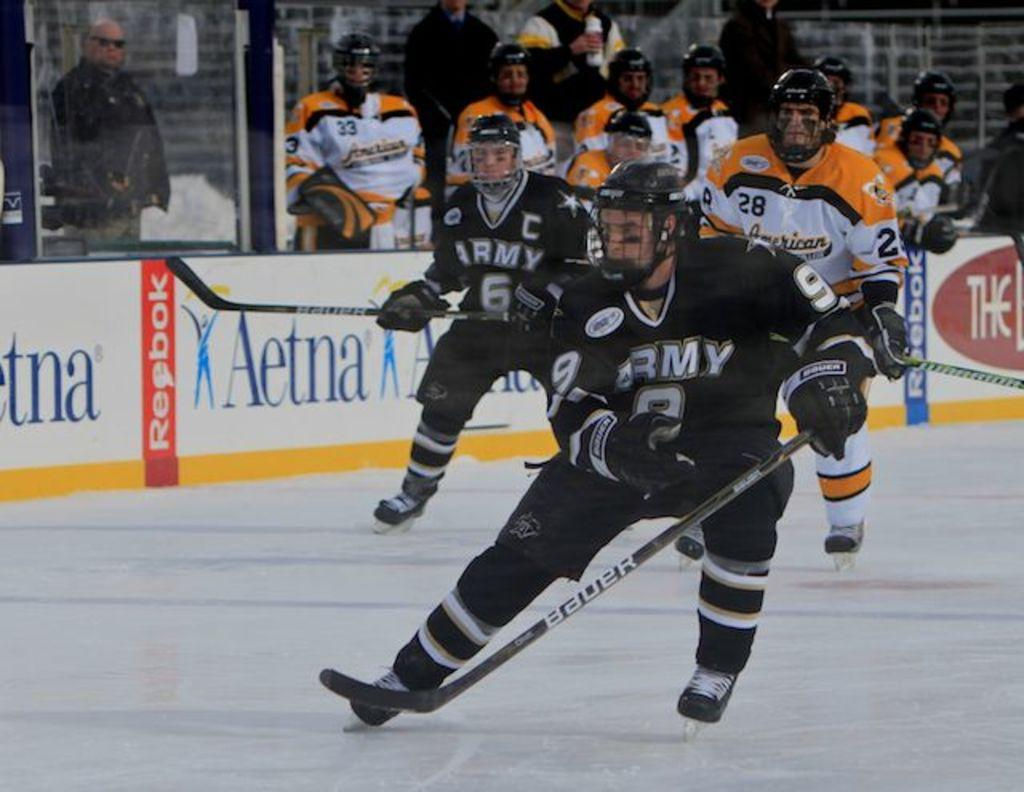<image>
Summarize the visual content of the image. Hockey players in black uniforms with ARMY in white on the jersey's. 